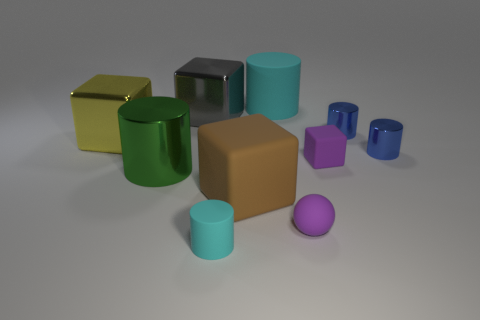Do the small object to the left of the large brown thing and the green shiny thing have the same shape?
Make the answer very short. Yes. Is the number of large cylinders that are in front of the gray metallic thing greater than the number of big red shiny objects?
Provide a succinct answer. Yes. What is the color of the rubber cylinder that is the same size as the brown matte cube?
Provide a short and direct response. Cyan. What number of things are either matte cylinders behind the small rubber cube or big cyan rubber things?
Offer a terse response. 1. What is the shape of the object that is the same color as the large rubber cylinder?
Provide a succinct answer. Cylinder. What is the material of the big cylinder that is left of the cyan rubber thing that is in front of the large cyan cylinder?
Your response must be concise. Metal. Are there any other large green objects that have the same material as the green object?
Your answer should be very brief. No. There is a purple rubber thing in front of the big brown thing; are there any blue metal cylinders that are left of it?
Offer a very short reply. No. There is a block that is right of the large brown rubber thing; what is it made of?
Give a very brief answer. Rubber. Is the brown object the same shape as the big green object?
Your answer should be very brief. No. 